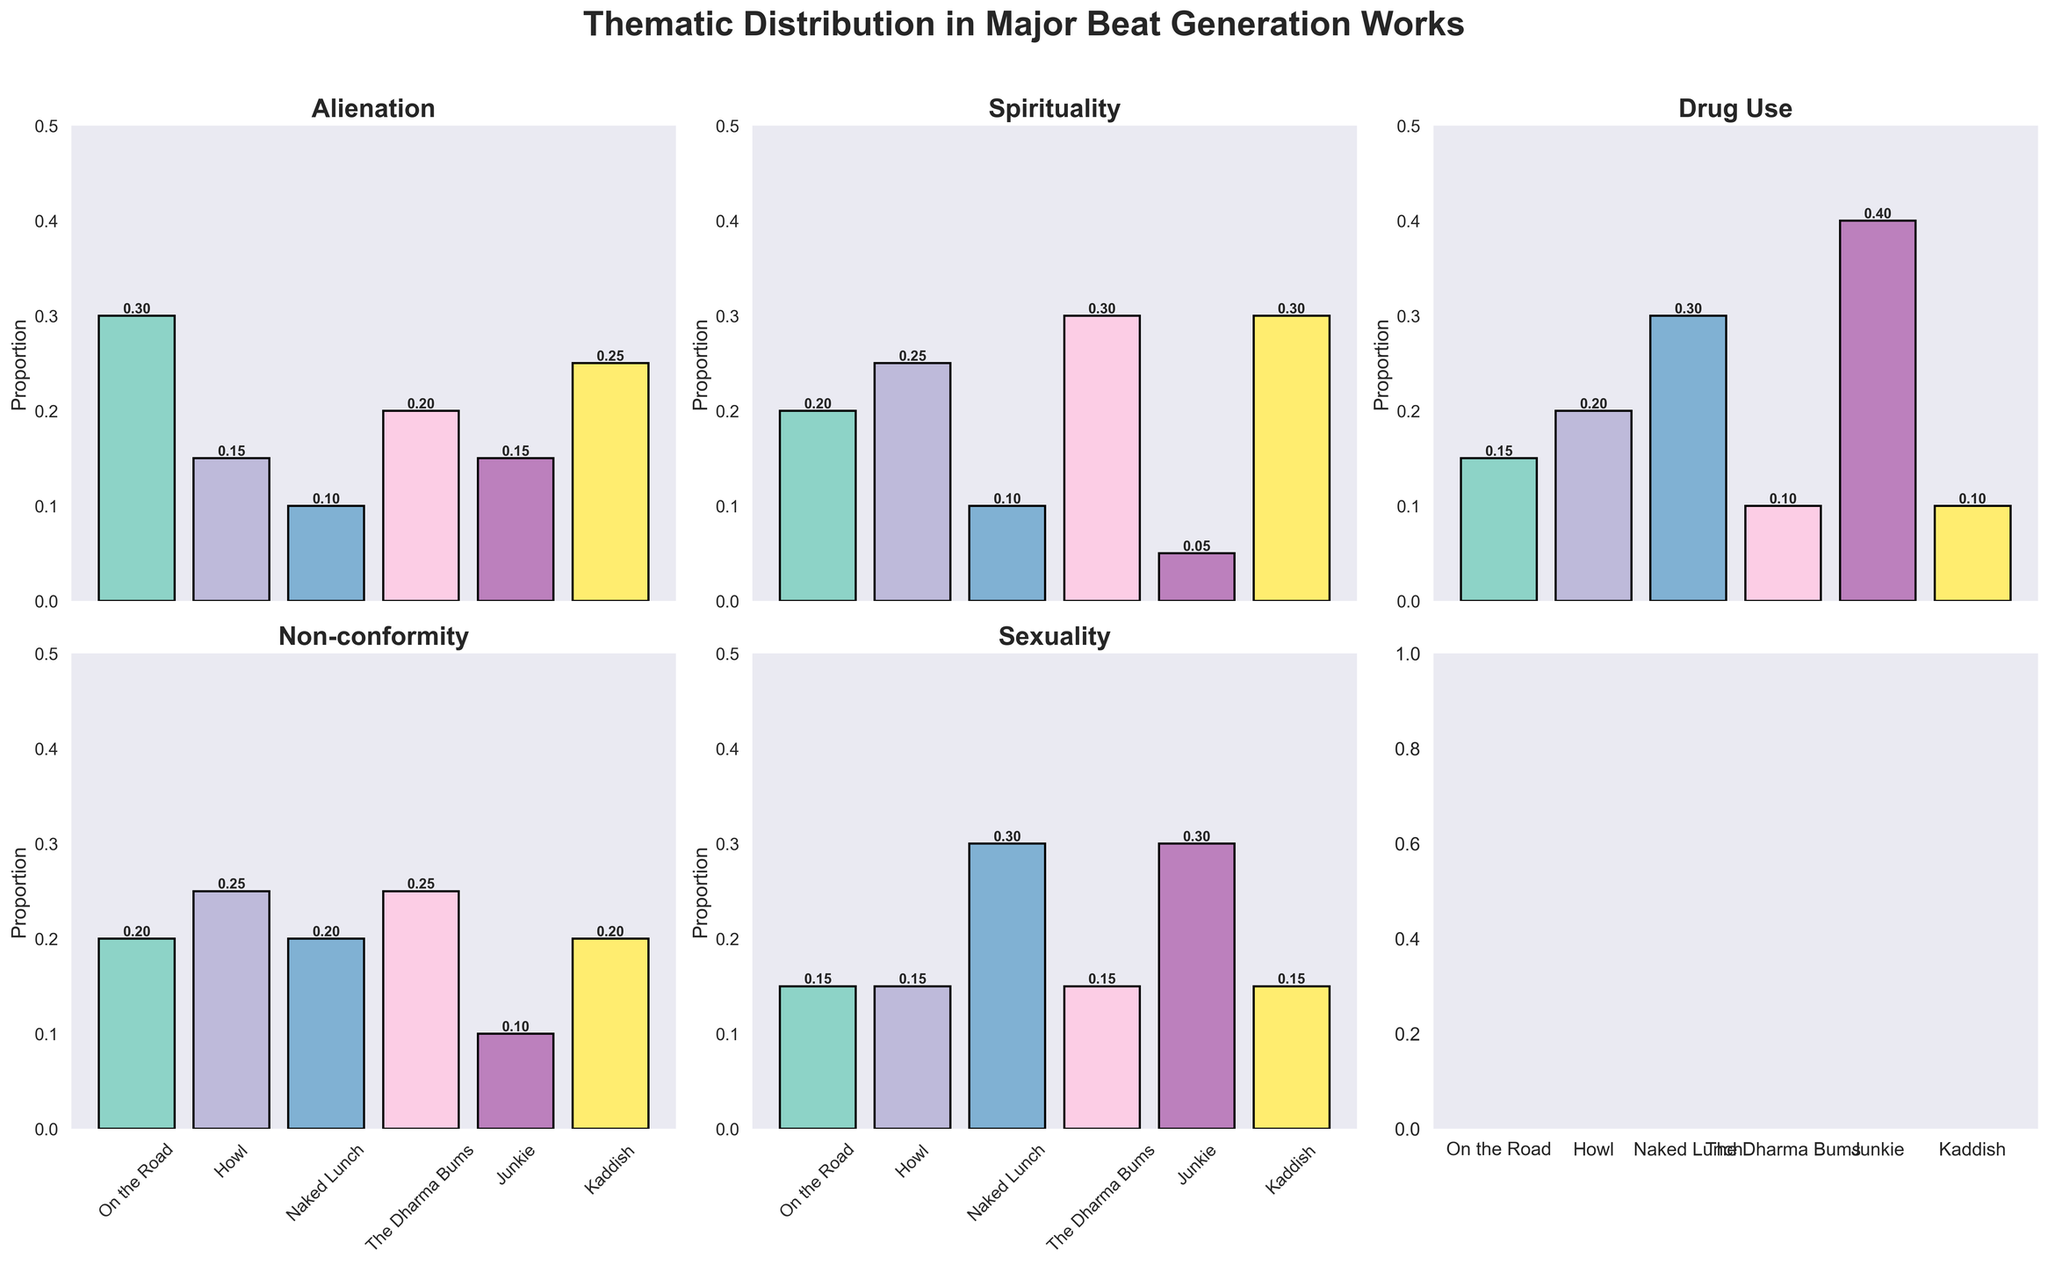What is the highest proportion of Alienation represented across all works? To find the highest proportion of Alienation, look at the “Alienation” subplot and identify the tallest bar. The tallest bar is for "On the Road" with a proportion of 0.3.
Answer: 0.3 Which work has the lowest representation of Spirituality? To identify the work with the lowest representation of Spirituality, look at the “Spirituality” subplot and check for the shortest bar. The shortest bar belongs to "Junkie" with a proportion of 0.05.
Answer: Junkie In which work is Drug Use the predominant theme? Look at the “Drug Use” subplot and find the bar with the highest value. The highest value is for "Junkie" with a proportion of 0.4.
Answer: Junkie Which two works have the same proportion value for Sexuality? In the “Sexuality” subplot, observe the bars and find two bars that are of equal height. Both "On the Road" and "Howl" have a proportion of 0.15 for Sexuality.
Answer: On the Road, Howl What is the average proportion of Non-conformity across all works? To calculate the average proportion for the Non-conformity theme, add all the proportions and divide by the number of works: (0.2 + 0.25 + 0.2 + 0.25 + 0.1 + 0.2) / 6 = 1.2 / 6 = 0.2.
Answer: 0.2 Which theme has the most uniform distribution across all works? To determine the theme with the most uniform distribution, visually inspect each subplot and compare the consistency of bar heights. The "Non-conformity" theme seems to have the closest values across all works.
Answer: Non-conformity Compare the proportions of Alienation between "On the Road" and "Kaddish." Which has a higher value, and by how much? Look at the “Alienation” subplot and compare the bars for "On the Road" and "Kaddish." "On the Road" has 0.3, and "Kaddish" has 0.25. Calculate the difference: 0.3 - 0.25 = 0.05.
Answer: On the Road, 0.05 What is the combined proportion for the themes of Sexuality and Drug Use in "Naked Lunch"? Add the values for Sexuality and Drug Use in "Naked Lunch" from their respective subplots: 0.3 (Sexuality) + 0.3 (Drug Use) = 0.6.
Answer: 0.6 Is there any work that has a proportion of 0.25 for more than one theme? If yes, identify the work and themes. Look through the subplots to identify any bar with a value of 0.25 in multiple themes for the same work. "Howl" has a proportion of 0.25 for both Spirituality and Non-conformity.
Answer: Howl, Spirituality and Non-conformity Which work shows the least variability in theme proportions, and what is the range of proportions for that work? To find the work with the least variability, look at the distribution of each theme for each work and find the one with the most similar heights. "On the Road" has values close to each other: 0.3, 0.2, 0.15, 0.2, 0.15. The range is 0.3 - 0.15 = 0.15.
Answer: On the Road, 0.15 